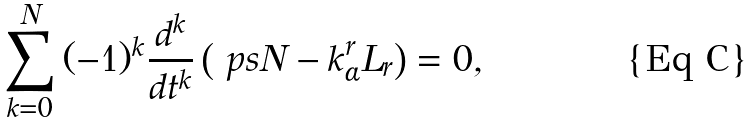<formula> <loc_0><loc_0><loc_500><loc_500>\sum _ { k = 0 } ^ { N } { ( - 1 ) ^ { k } \frac { d ^ { k } } { d t ^ { k } } \left ( \ p s { N - k } ^ { r } _ { \alpha } L _ { r } \right ) } = 0 ,</formula> 